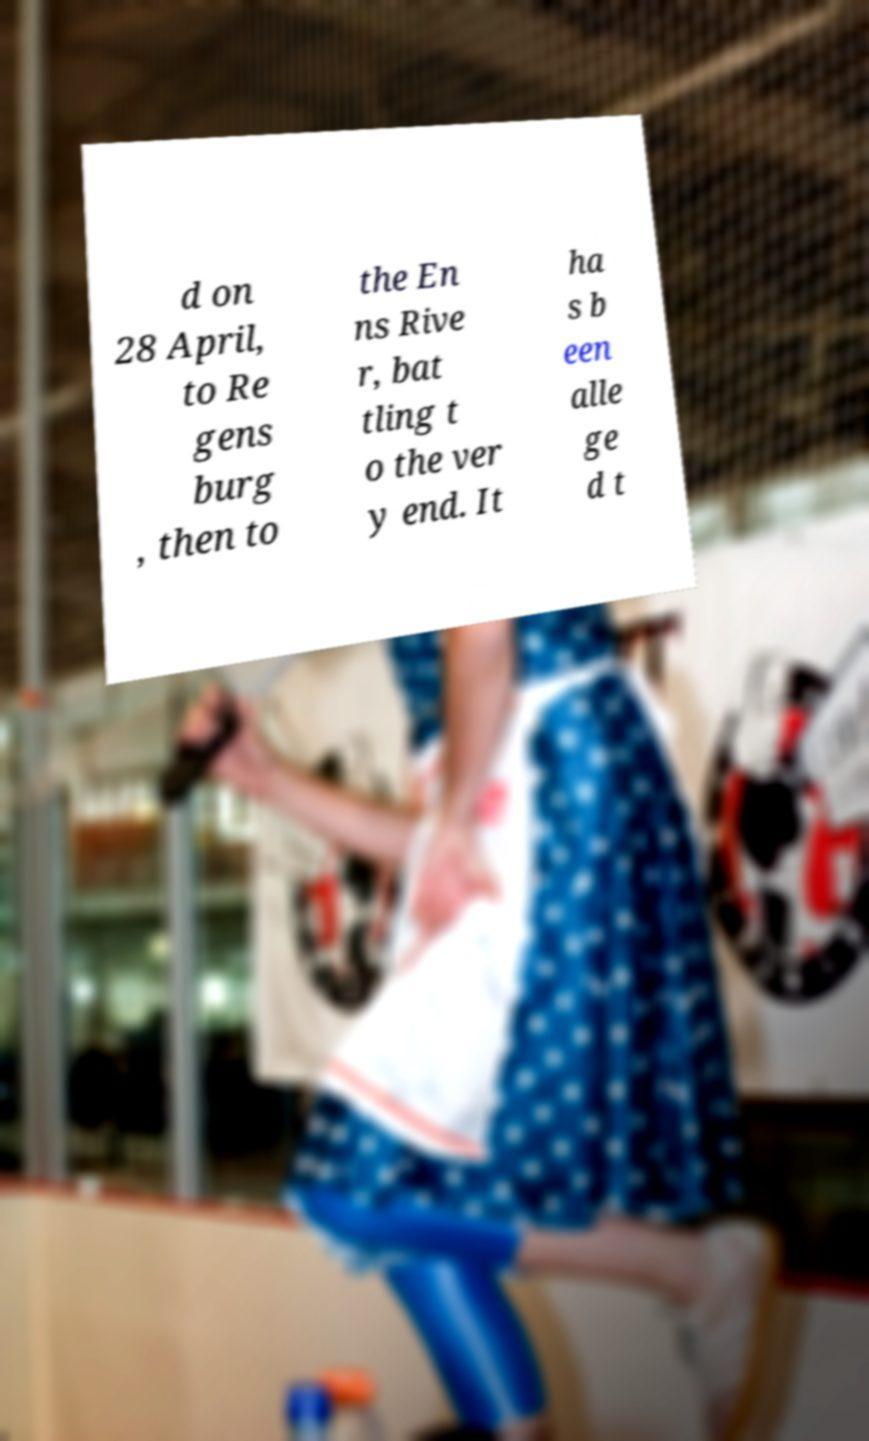Could you extract and type out the text from this image? d on 28 April, to Re gens burg , then to the En ns Rive r, bat tling t o the ver y end. It ha s b een alle ge d t 